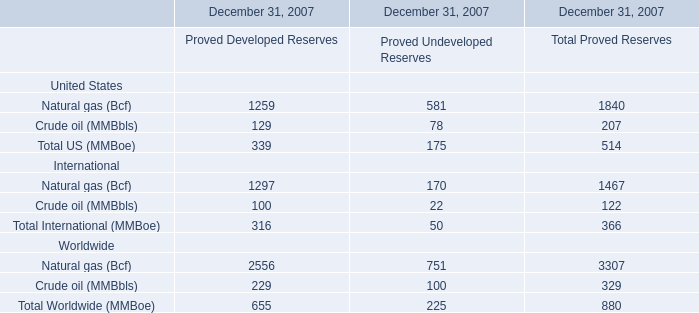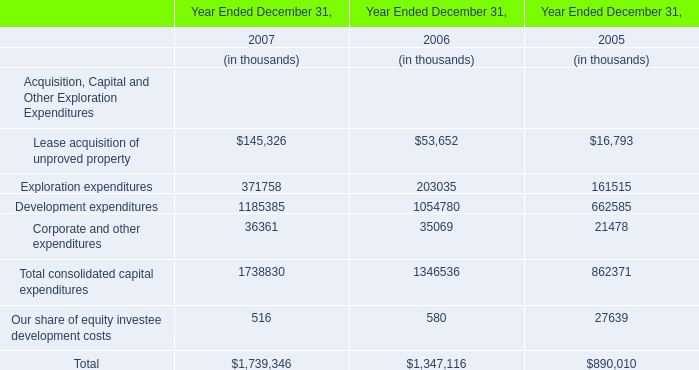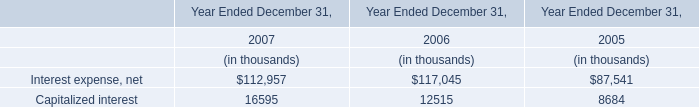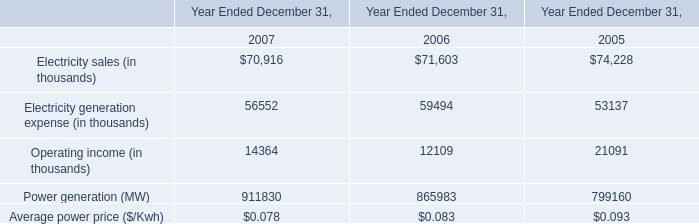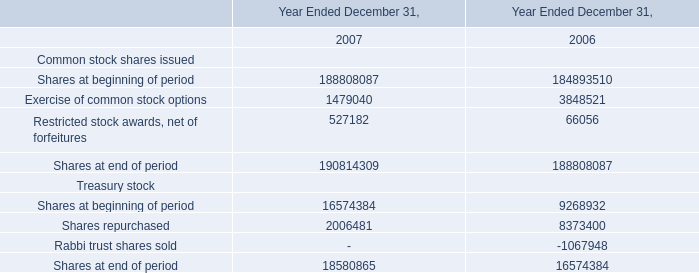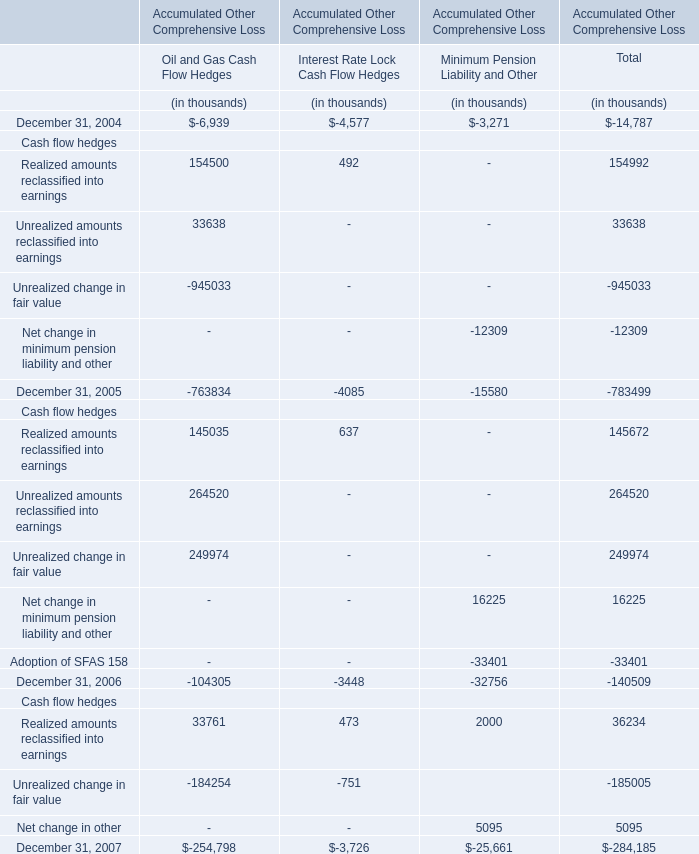Which year has the greatest proportion of Oil and Gas Cash Flow Hedges? (in thousand) 
Answer: 2005. 